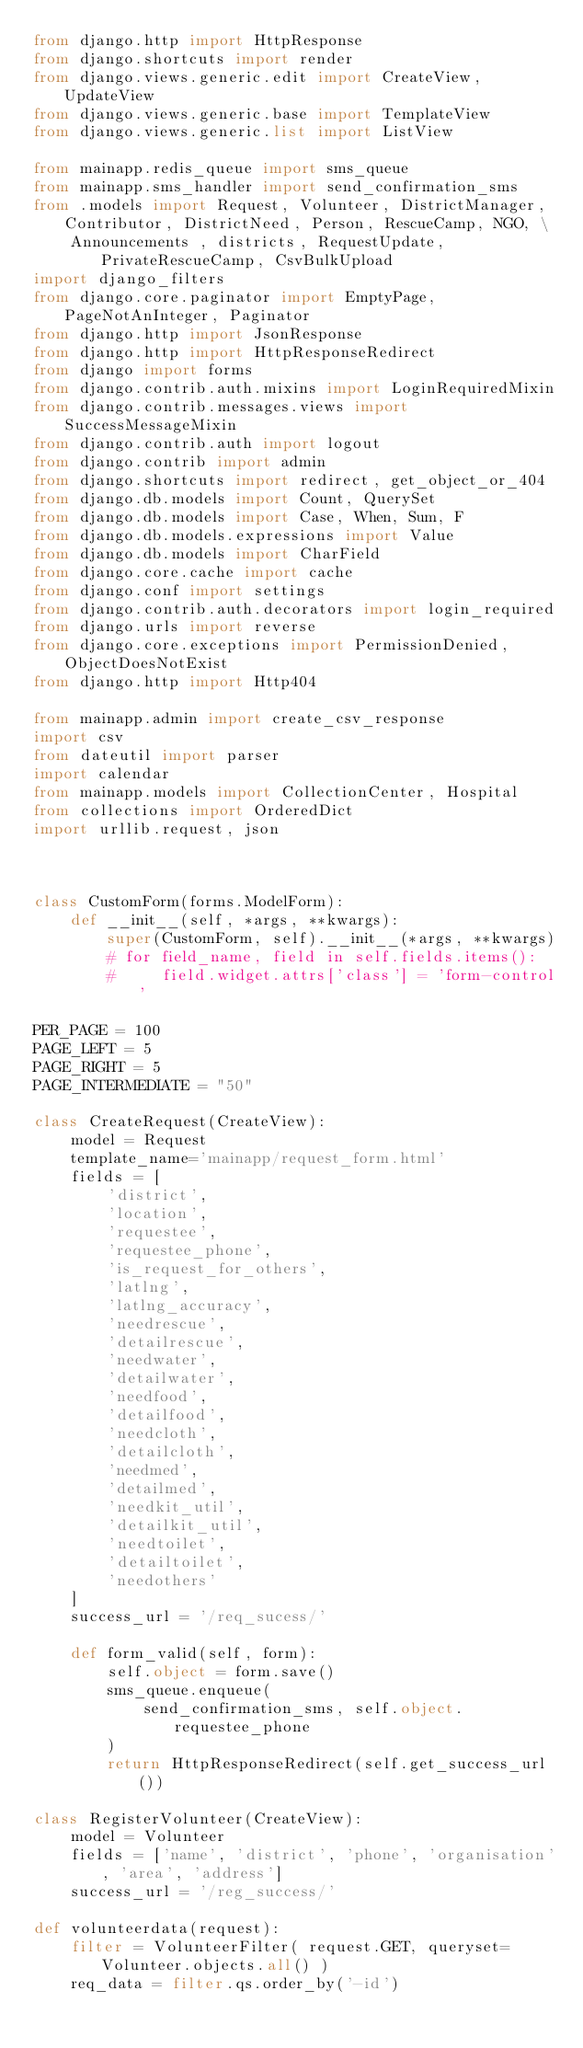<code> <loc_0><loc_0><loc_500><loc_500><_Python_>from django.http import HttpResponse
from django.shortcuts import render
from django.views.generic.edit import CreateView, UpdateView
from django.views.generic.base import TemplateView
from django.views.generic.list import ListView

from mainapp.redis_queue import sms_queue
from mainapp.sms_handler import send_confirmation_sms
from .models import Request, Volunteer, DistrictManager, Contributor, DistrictNeed, Person, RescueCamp, NGO, \
    Announcements , districts, RequestUpdate, PrivateRescueCamp, CsvBulkUpload
import django_filters
from django.core.paginator import EmptyPage, PageNotAnInteger, Paginator
from django.http import JsonResponse
from django.http import HttpResponseRedirect
from django import forms
from django.contrib.auth.mixins import LoginRequiredMixin
from django.contrib.messages.views import SuccessMessageMixin
from django.contrib.auth import logout
from django.contrib import admin
from django.shortcuts import redirect, get_object_or_404
from django.db.models import Count, QuerySet
from django.db.models import Case, When, Sum, F
from django.db.models.expressions import Value
from django.db.models import CharField
from django.core.cache import cache
from django.conf import settings
from django.contrib.auth.decorators import login_required
from django.urls import reverse
from django.core.exceptions import PermissionDenied, ObjectDoesNotExist
from django.http import Http404

from mainapp.admin import create_csv_response
import csv
from dateutil import parser
import calendar
from mainapp.models import CollectionCenter, Hospital
from collections import OrderedDict
import urllib.request, json 



class CustomForm(forms.ModelForm):
    def __init__(self, *args, **kwargs):
        super(CustomForm, self).__init__(*args, **kwargs)
        # for field_name, field in self.fields.items():
        #     field.widget.attrs['class'] = 'form-control'

PER_PAGE = 100
PAGE_LEFT = 5
PAGE_RIGHT = 5
PAGE_INTERMEDIATE = "50"

class CreateRequest(CreateView):
    model = Request
    template_name='mainapp/request_form.html'
    fields = [
        'district',
        'location',
        'requestee',
        'requestee_phone',
        'is_request_for_others',
        'latlng',
        'latlng_accuracy',
        'needrescue',
        'detailrescue',
        'needwater',
        'detailwater',
        'needfood',
        'detailfood',
        'needcloth',
        'detailcloth',
        'needmed',
        'detailmed',
        'needkit_util',
        'detailkit_util',
        'needtoilet',
        'detailtoilet',
        'needothers'
    ]
    success_url = '/req_sucess/'

    def form_valid(self, form):
        self.object = form.save()
        sms_queue.enqueue(
            send_confirmation_sms, self.object.requestee_phone
        )
        return HttpResponseRedirect(self.get_success_url())

class RegisterVolunteer(CreateView):
    model = Volunteer
    fields = ['name', 'district', 'phone', 'organisation', 'area', 'address']
    success_url = '/reg_success/'

def volunteerdata(request):
    filter = VolunteerFilter( request.GET, queryset=Volunteer.objects.all() )
    req_data = filter.qs.order_by('-id')</code> 